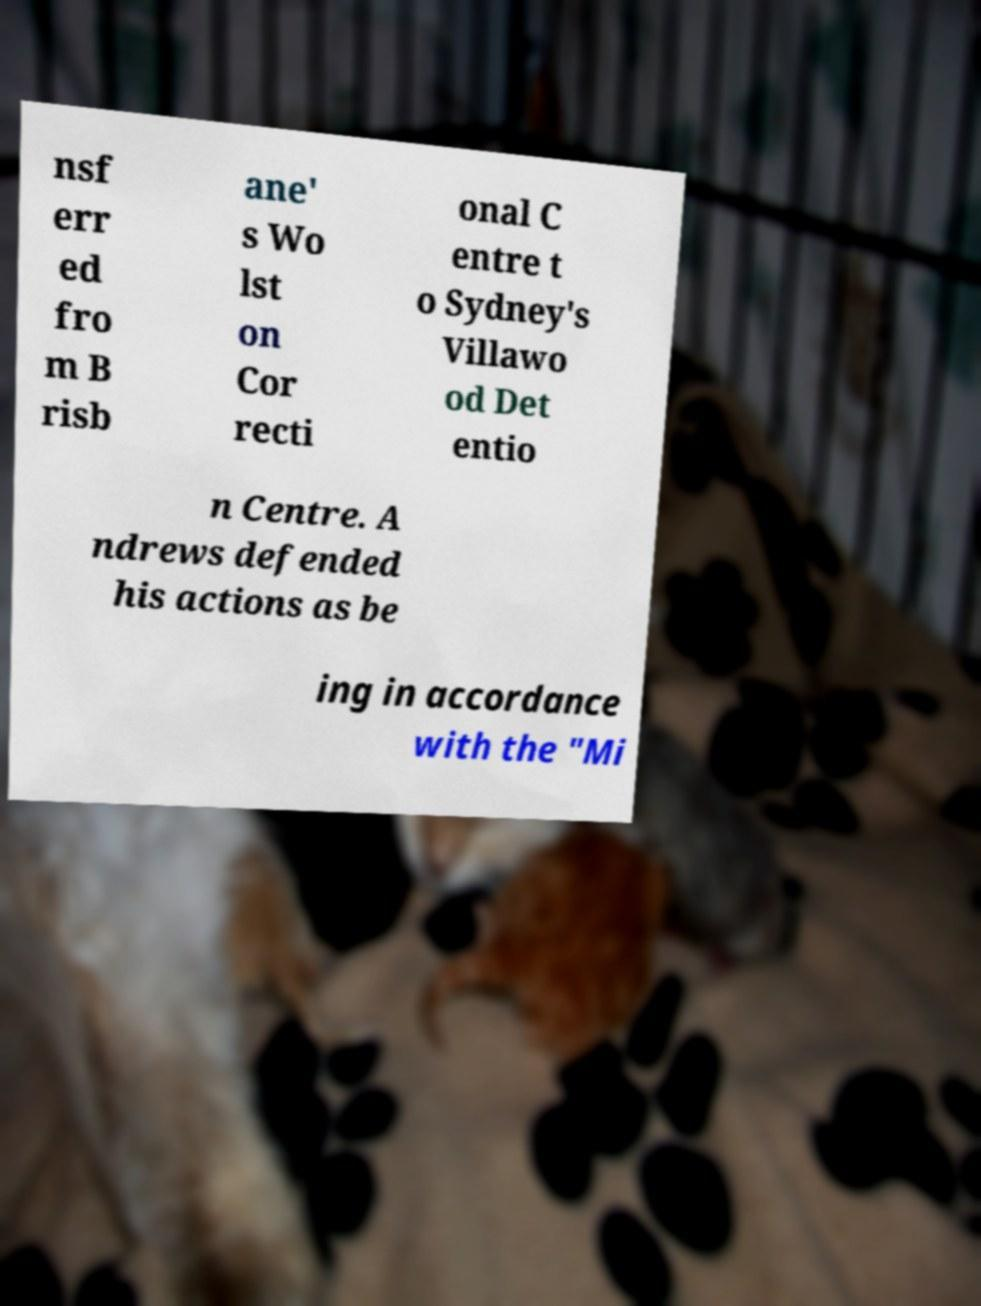Can you read and provide the text displayed in the image?This photo seems to have some interesting text. Can you extract and type it out for me? nsf err ed fro m B risb ane' s Wo lst on Cor recti onal C entre t o Sydney's Villawo od Det entio n Centre. A ndrews defended his actions as be ing in accordance with the "Mi 